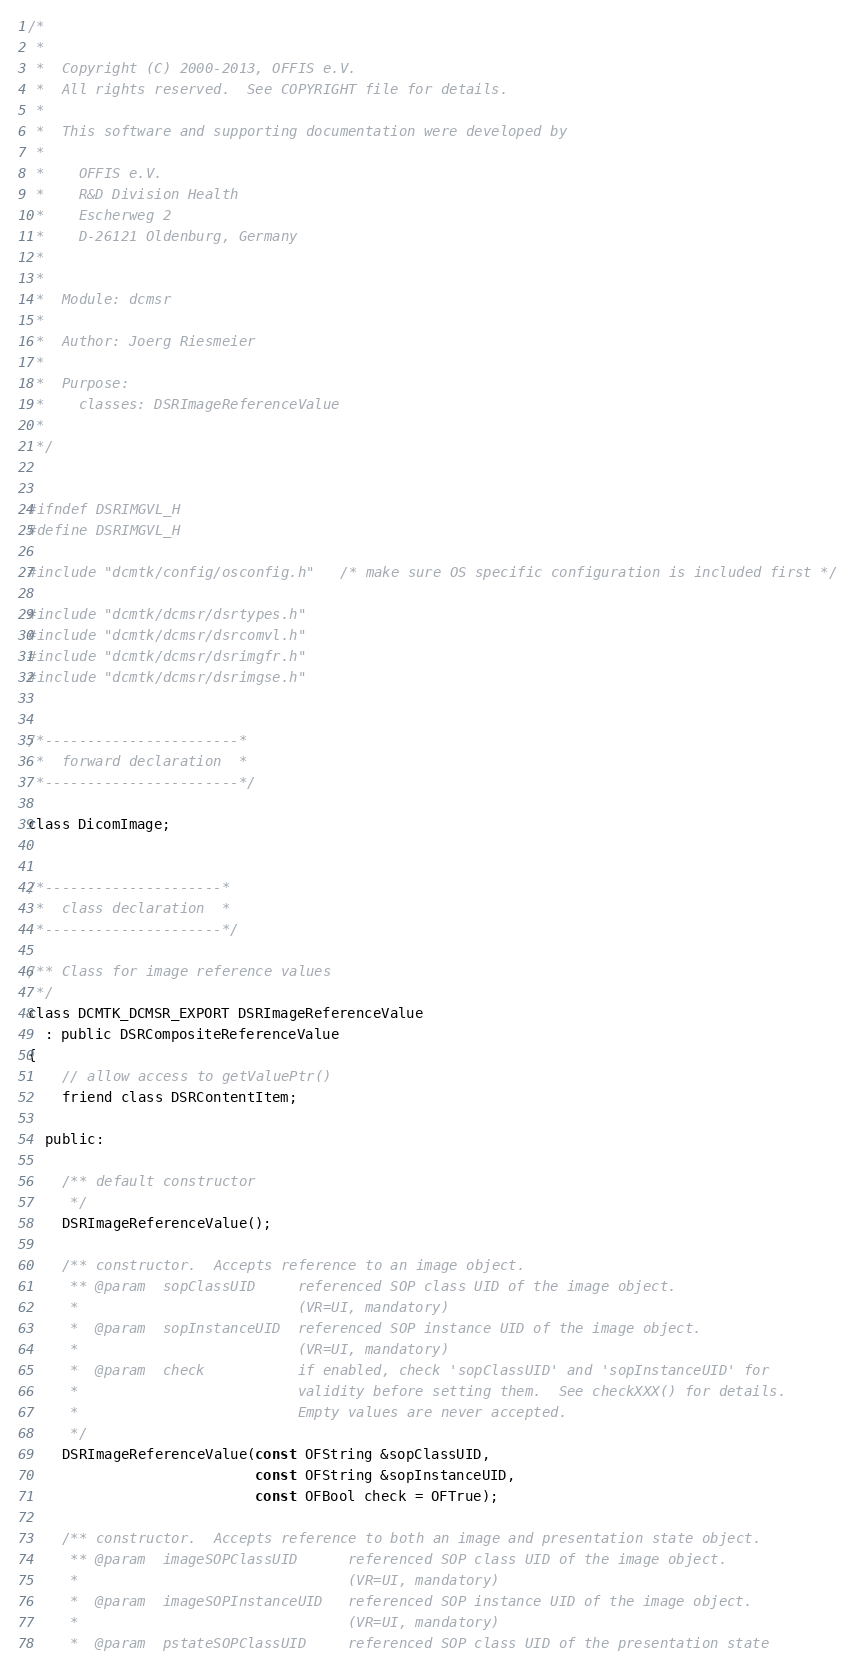<code> <loc_0><loc_0><loc_500><loc_500><_C_>/*
 *
 *  Copyright (C) 2000-2013, OFFIS e.V.
 *  All rights reserved.  See COPYRIGHT file for details.
 *
 *  This software and supporting documentation were developed by
 *
 *    OFFIS e.V.
 *    R&D Division Health
 *    Escherweg 2
 *    D-26121 Oldenburg, Germany
 *
 *
 *  Module: dcmsr
 *
 *  Author: Joerg Riesmeier
 *
 *  Purpose:
 *    classes: DSRImageReferenceValue
 *
 */


#ifndef DSRIMGVL_H
#define DSRIMGVL_H

#include "dcmtk/config/osconfig.h"   /* make sure OS specific configuration is included first */

#include "dcmtk/dcmsr/dsrtypes.h"
#include "dcmtk/dcmsr/dsrcomvl.h"
#include "dcmtk/dcmsr/dsrimgfr.h"
#include "dcmtk/dcmsr/dsrimgse.h"


/*-----------------------*
 *  forward declaration  *
 *-----------------------*/

class DicomImage;


/*---------------------*
 *  class declaration  *
 *---------------------*/

/** Class for image reference values
 */
class DCMTK_DCMSR_EXPORT DSRImageReferenceValue
  : public DSRCompositeReferenceValue
{
    // allow access to getValuePtr()
    friend class DSRContentItem;

  public:

    /** default constructor
     */
    DSRImageReferenceValue();

    /** constructor.  Accepts reference to an image object.
     ** @param  sopClassUID     referenced SOP class UID of the image object.
     *                          (VR=UI, mandatory)
     *  @param  sopInstanceUID  referenced SOP instance UID of the image object.
     *                          (VR=UI, mandatory)
     *  @param  check           if enabled, check 'sopClassUID' and 'sopInstanceUID' for
     *                          validity before setting them.  See checkXXX() for details.
     *                          Empty values are never accepted.
     */
    DSRImageReferenceValue(const OFString &sopClassUID,
                           const OFString &sopInstanceUID,
                           const OFBool check = OFTrue);

    /** constructor.  Accepts reference to both an image and presentation state object.
     ** @param  imageSOPClassUID      referenced SOP class UID of the image object.
     *                                (VR=UI, mandatory)
     *  @param  imageSOPInstanceUID   referenced SOP instance UID of the image object.
     *                                (VR=UI, mandatory)
     *  @param  pstateSOPClassUID     referenced SOP class UID of the presentation state</code> 